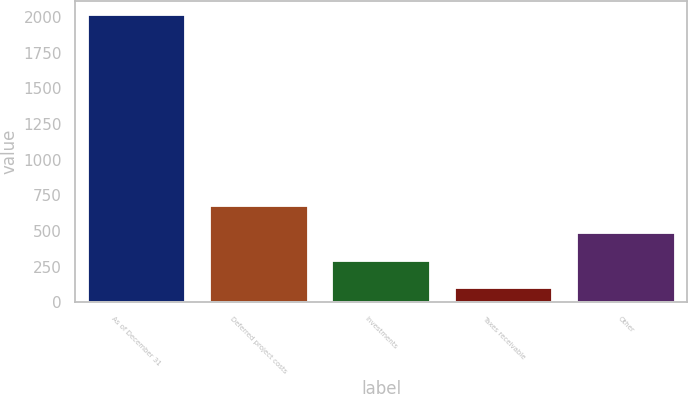Convert chart to OTSL. <chart><loc_0><loc_0><loc_500><loc_500><bar_chart><fcel>As of December 31<fcel>Deferred project costs<fcel>Investments<fcel>Taxes receivable<fcel>Other<nl><fcel>2014<fcel>674.9<fcel>292.3<fcel>101<fcel>483.6<nl></chart> 